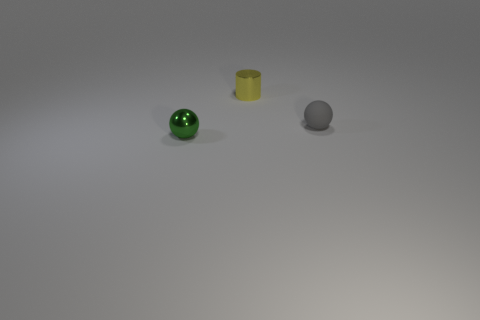Add 1 tiny gray matte spheres. How many objects exist? 4 Subtract all spheres. How many objects are left? 1 Add 2 small rubber things. How many small rubber things exist? 3 Subtract all green spheres. How many spheres are left? 1 Subtract 0 brown balls. How many objects are left? 3 Subtract 1 cylinders. How many cylinders are left? 0 Subtract all brown balls. Subtract all brown cylinders. How many balls are left? 2 Subtract all cyan cylinders. How many gray balls are left? 1 Subtract all blue balls. Subtract all metal cylinders. How many objects are left? 2 Add 1 green metallic balls. How many green metallic balls are left? 2 